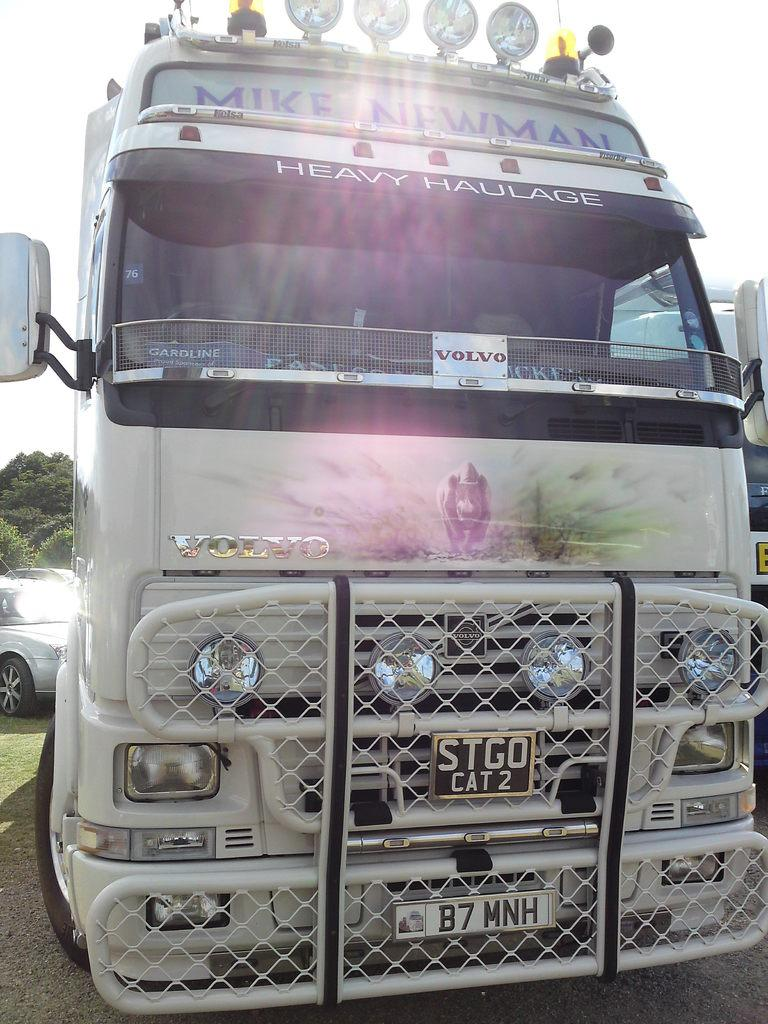<image>
Present a compact description of the photo's key features. A truck made by Volvo does heavy hauling. 